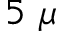Convert formula to latex. <formula><loc_0><loc_0><loc_500><loc_500>5 \mu</formula> 